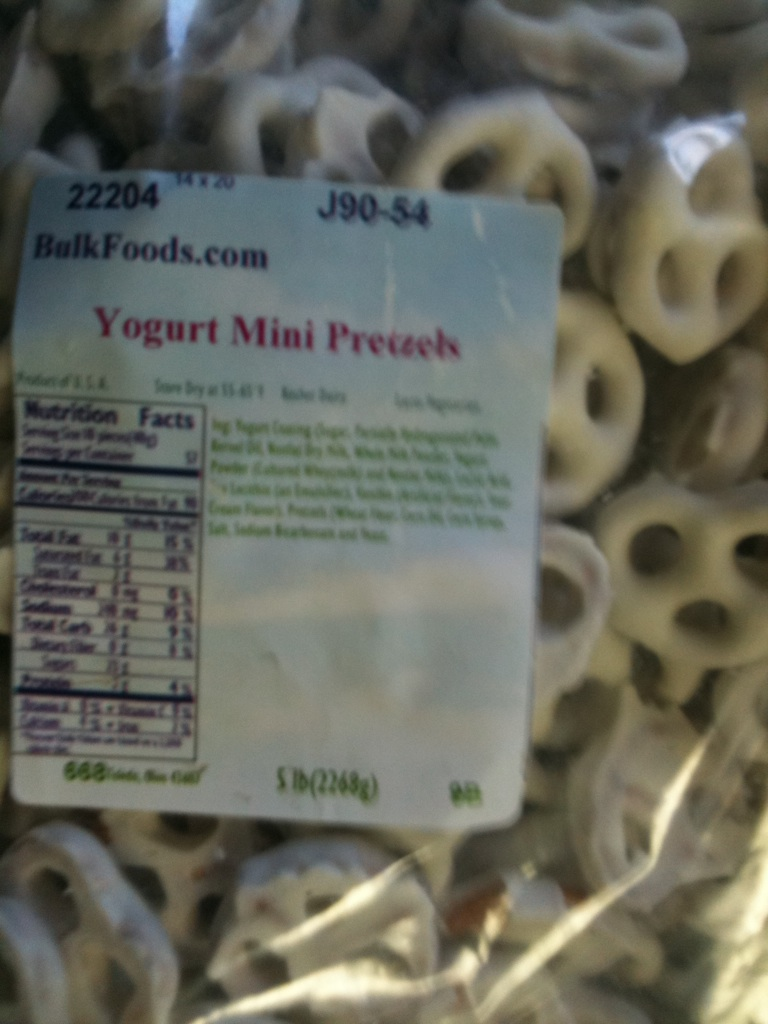What is this item? This is a package of Yogurt Mini Pretzels, which are small pretzels coated in a creamy yogurt layer. They are a popular snack for their crunchy texture and slightly sweet flavor. 